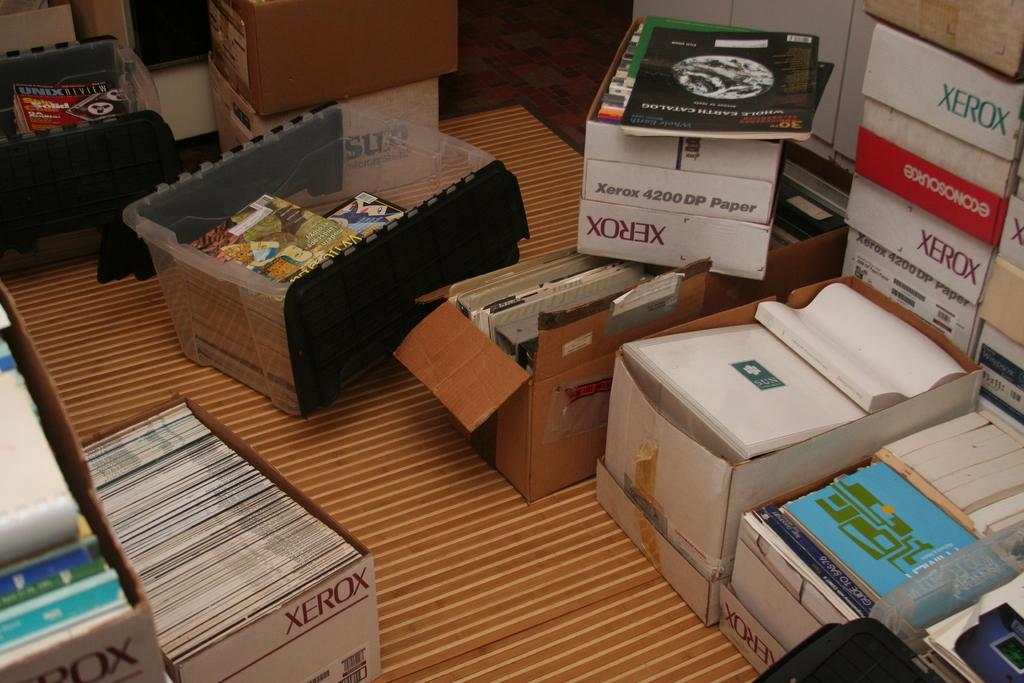<image>
Relay a brief, clear account of the picture shown. Xerox boxes are filled with magazines and books. 